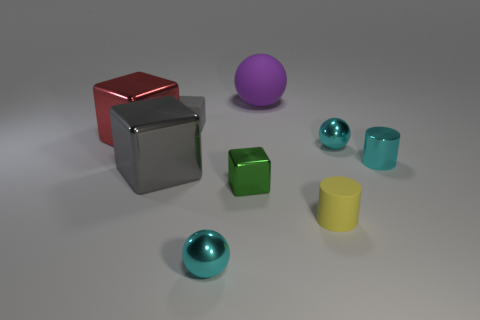Subtract 1 blocks. How many blocks are left? 3 Add 1 big rubber balls. How many objects exist? 10 Subtract all cylinders. How many objects are left? 7 Add 6 red shiny blocks. How many red shiny blocks exist? 7 Subtract 0 brown cylinders. How many objects are left? 9 Subtract all red shiny cylinders. Subtract all shiny balls. How many objects are left? 7 Add 7 large metal things. How many large metal things are left? 9 